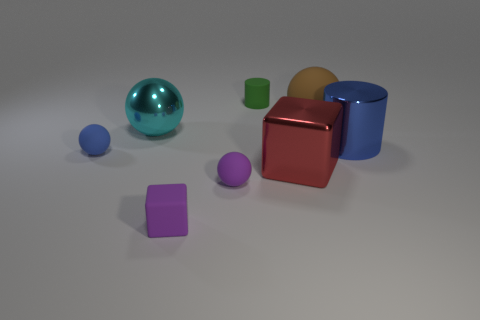How is the lighting affecting the appearance of the objects? The lighting in the image is creating soft shadows on the right side of the objects, suggesting the light source is coming from the left. This gives a sense of depth and dimension to the objects.  Which object appears closest to the light source? The large blue reflective sphere appears to be closest to the light source, as it has the brightest reflection and the least amount of shadow on it. 